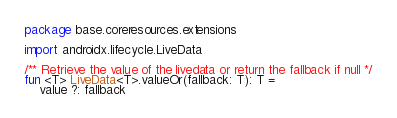<code> <loc_0><loc_0><loc_500><loc_500><_Kotlin_>package base.coreresources.extensions

import androidx.lifecycle.LiveData

/** Retrieve the value of the livedata or return the fallback if null */
fun <T> LiveData<T>.valueOr(fallback: T): T =
    value ?: fallback
</code> 